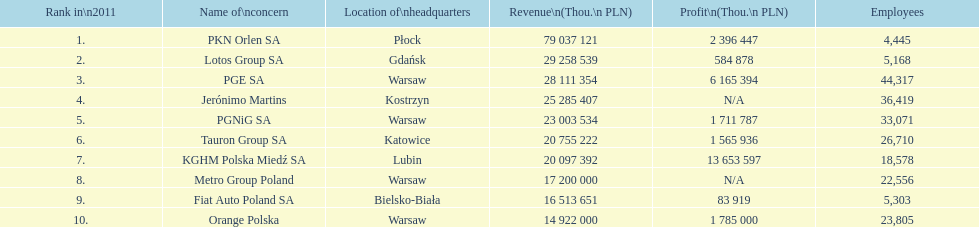What company has 28 111 354 thou.in revenue? PGE SA. What revenue does lotus group sa have? 29 258 539. Who has the next highest revenue than lotus group sa? PKN Orlen SA. 